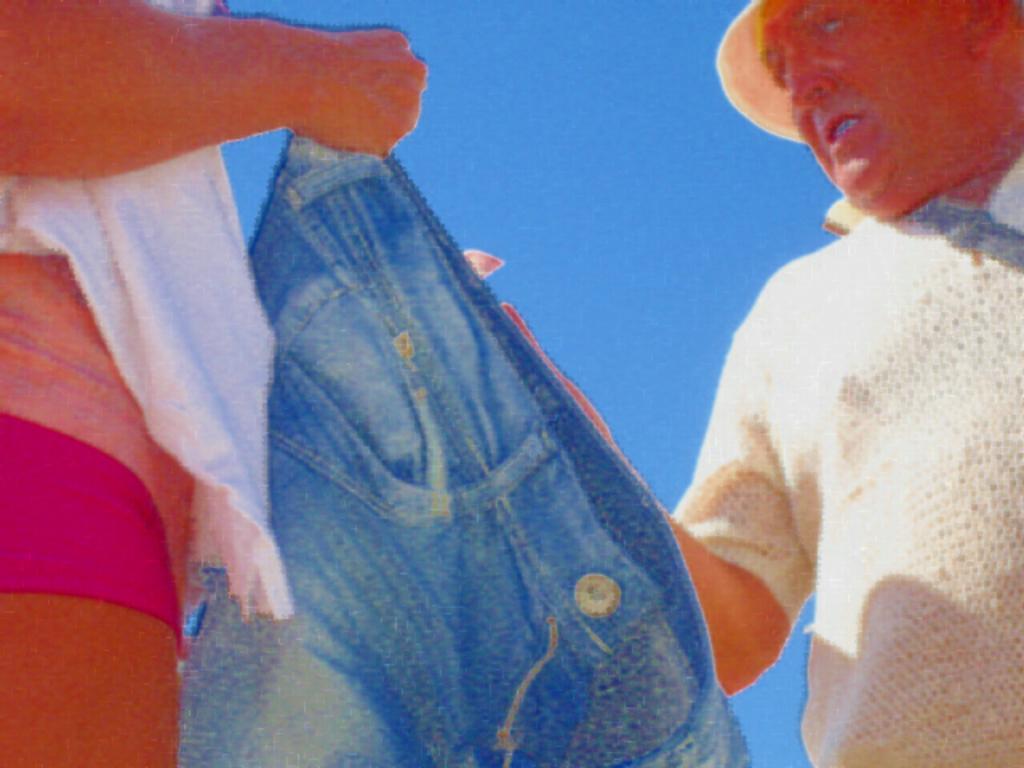Could you give a brief overview of what you see in this image? It looks like an edited image, we can see there are two people standing and a person is holding a jeans. Behind the people there is the sky. 